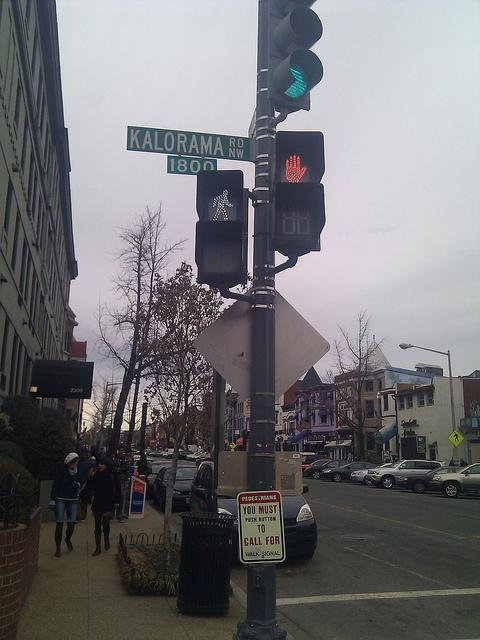The first three letters of the name of the street form the first name of what actor?

Choices:
A) jim beaver
B) kal penn
C) joe pesci
D) michael keaton kal penn 